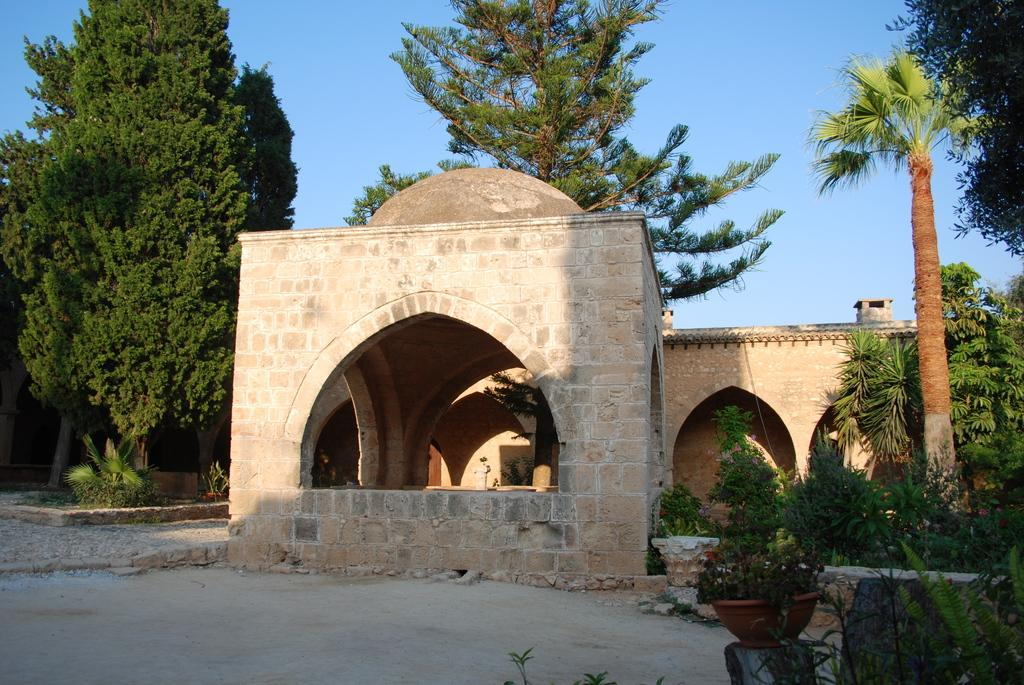What type of building is in the image? There is a cream-colored building in the image. What other natural elements can be seen in the image? There are plants and trees in the image. What is visible in the background of the image? The sky is visible in the background of the image. What type of honey is being served at the chess match in the image? There is no chess match or honey present in the image. 